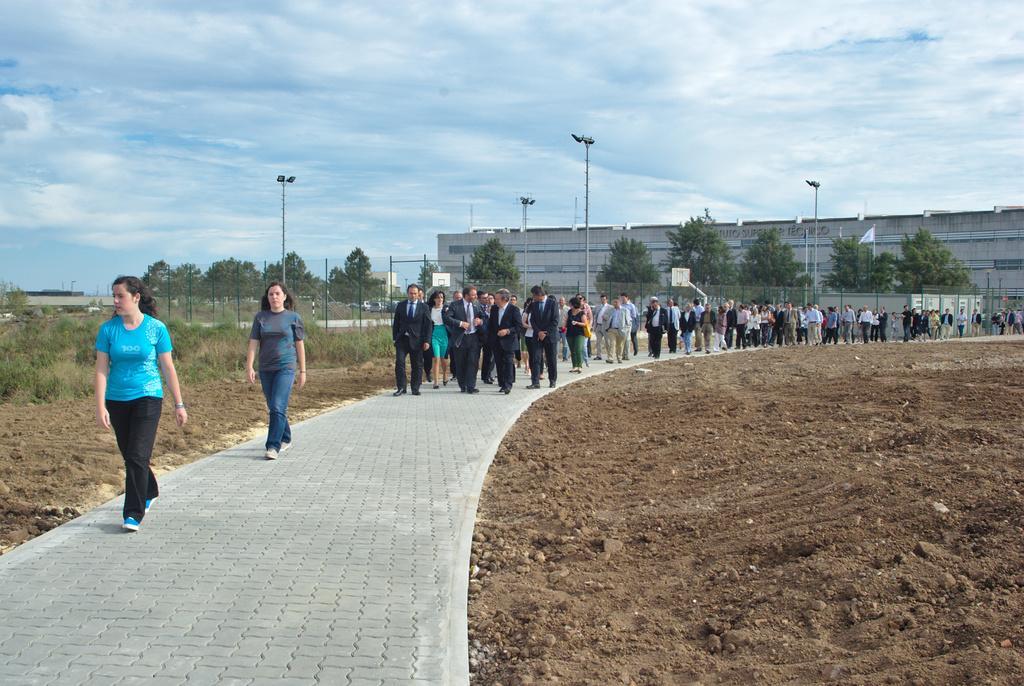Describe this image in one or two sentences. There are people walking in the center of the image, there are trees, poles, buildings, posters and the sky in the background. 